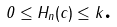<formula> <loc_0><loc_0><loc_500><loc_500>0 \leq H _ { n } ( c ) \leq k \text {.}</formula> 